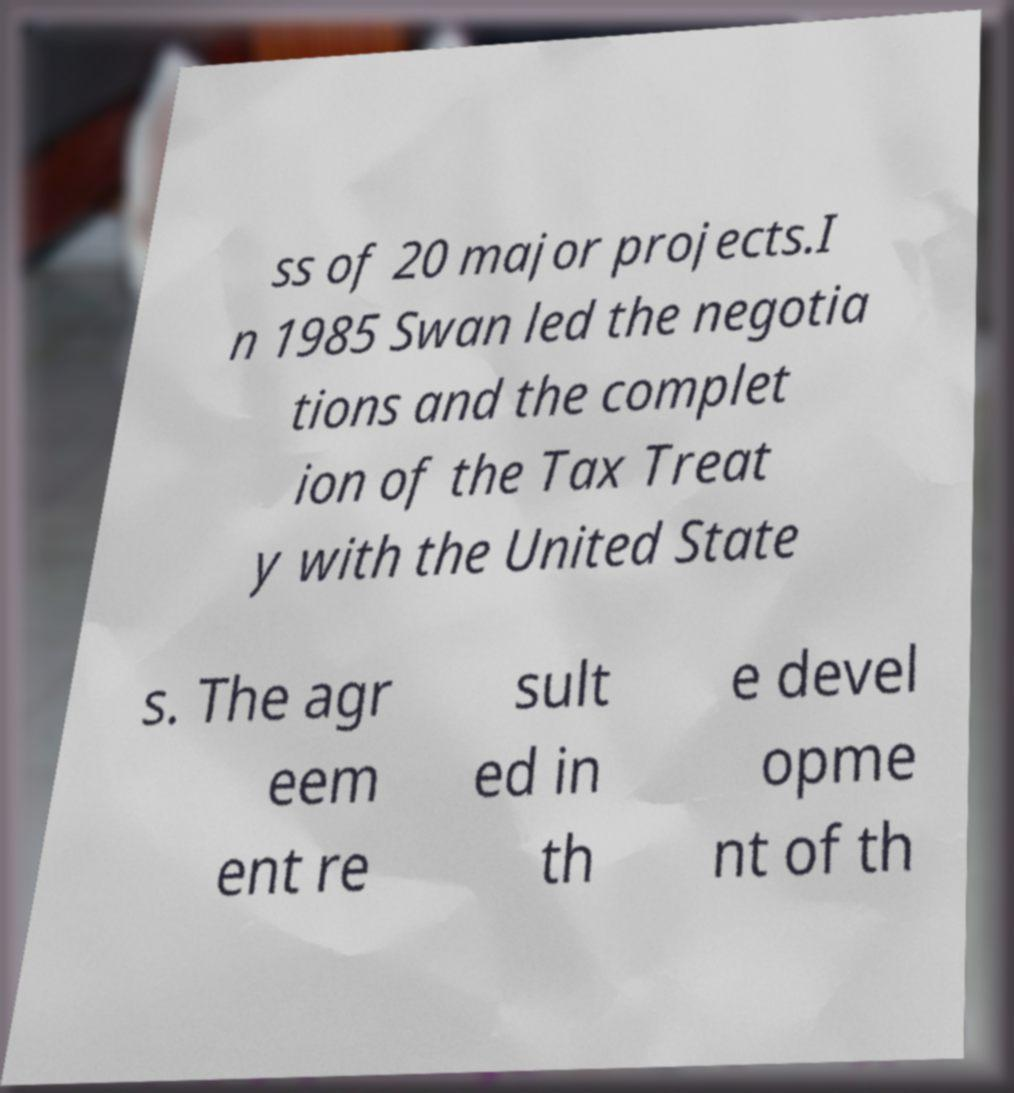What messages or text are displayed in this image? I need them in a readable, typed format. ss of 20 major projects.I n 1985 Swan led the negotia tions and the complet ion of the Tax Treat y with the United State s. The agr eem ent re sult ed in th e devel opme nt of th 